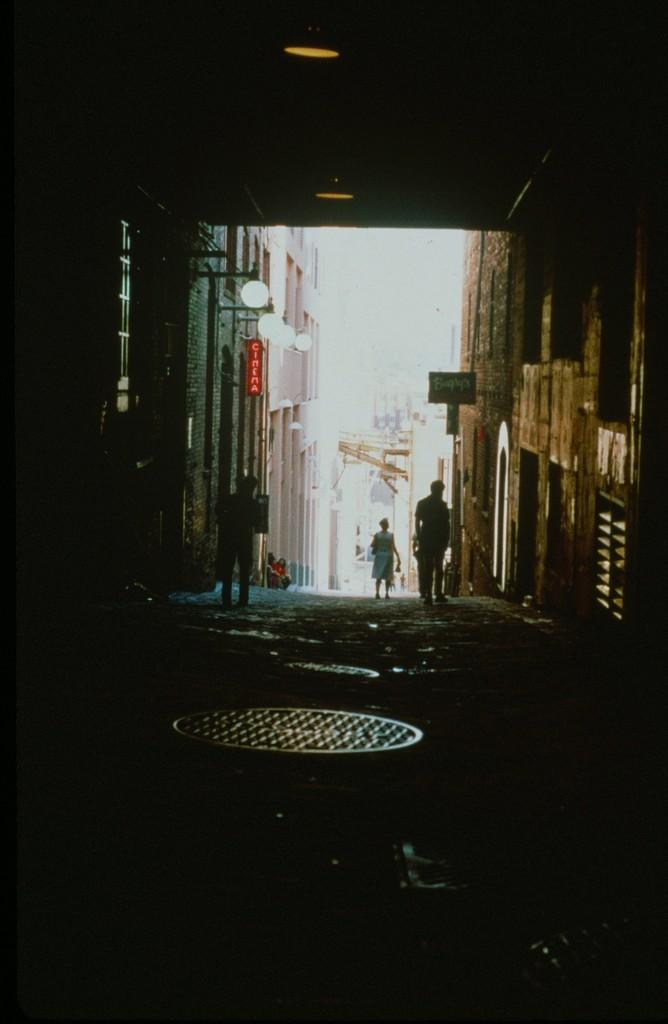How many people are present in the image? There are persons in the image, but the exact number is not specified. What type of structures can be seen in the image? There are buildings in the image. What objects are present in the image that might be used for displaying information or advertisements? There are boards in the image. What other objects can be seen in the image that might be related to infrastructure or utilities? There are poles and lights in the image. What can be seen in the background of the image? The sky is visible in the background of the image. How would you describe the lighting conditions in the foreground of the image? The front of the image appears dark. Can you tell me what type of cake is being requested by the person in the image? There is no cake present in the image, nor is there any indication of a request being made. 